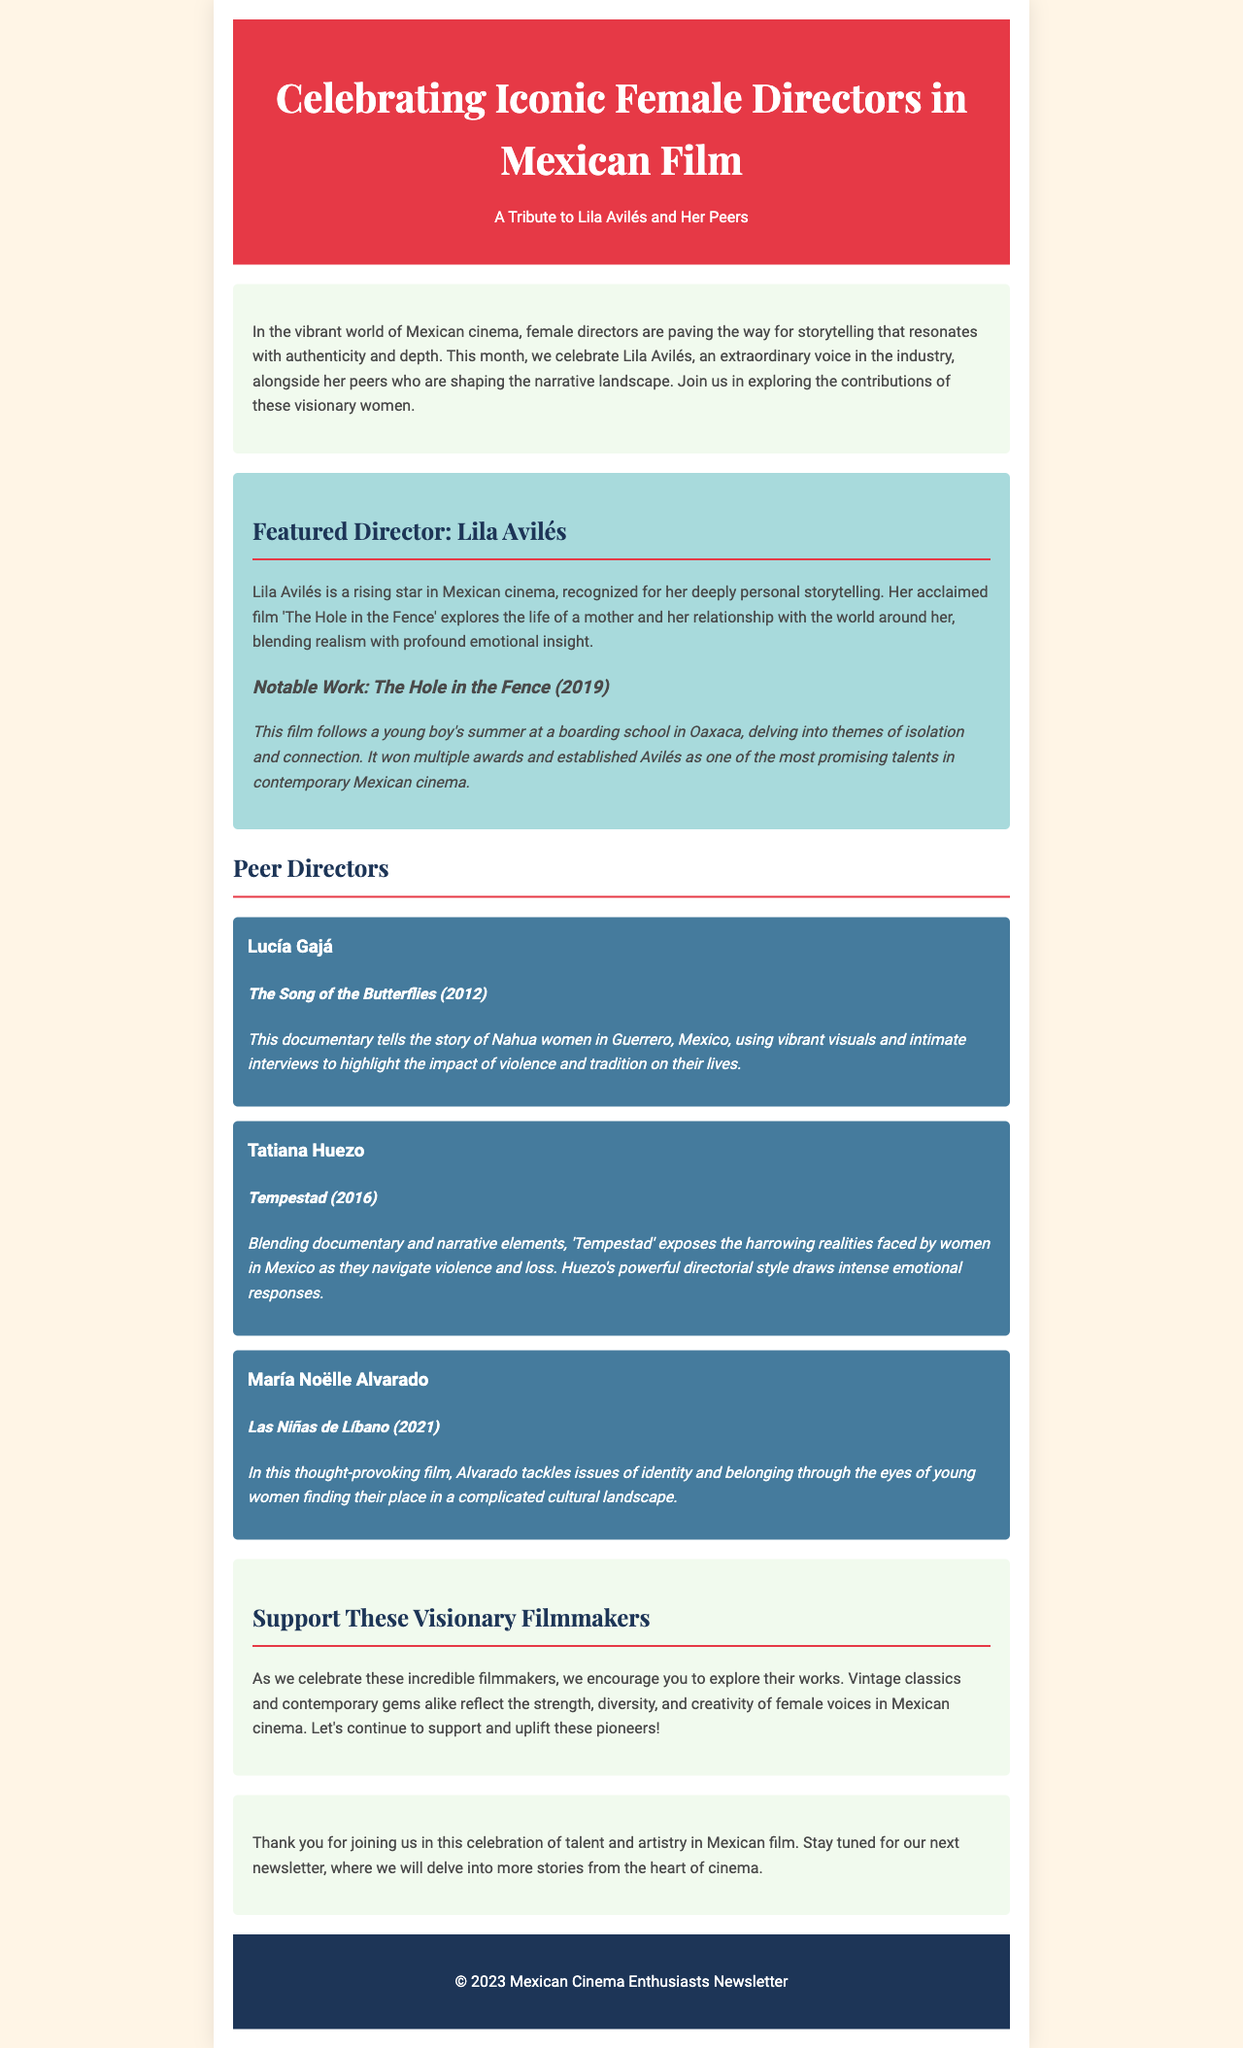What is the title of the newsletter? The title is prominently displayed at the top of the document, indicating the focus of the newsletter.
Answer: Celebrating Iconic Female Directors in Mexican Film Who is the featured director in the newsletter? The newsletter highlights a specific director, showcasing her work and impact.
Answer: Lila Avilés What year was "The Hole in the Fence" released? The document provides the release year of Lila Avilés' notable work.
Answer: 2019 How many peer directors are mentioned in the newsletter? The newsletter lists three peer directors in addition to the featured director.
Answer: Three Which documentary was created by Lucía Gajá? The document specifies one of the notable works from Lucía Gajá.
Answer: The Song of the Butterflies What key themes does Tatiana Huezo explore in "Tempestad"? The newsletter explains the main focus of Tatiana Huezo’s film, emphasizing its content.
Answer: Violence and loss What type of filmmakers are being celebrated in the newsletter? The introduction section describes the overall theme of the newsletter, which relates to a specific group of artists.
Answer: Female directors What action does the newsletter encourage readers to take? The call-to-action section suggests a particular way for readers to engage with the filmmakers' work.
Answer: Explore their works 